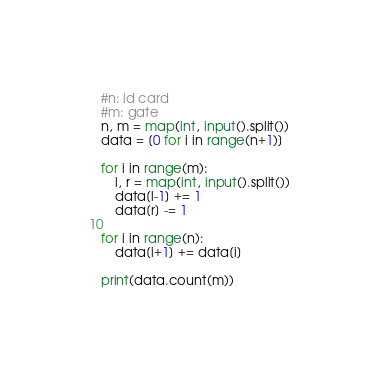<code> <loc_0><loc_0><loc_500><loc_500><_Python_>#n: id card
#m: gate
n, m = map(int, input().split())
data = [0 for i in range(n+1)]

for i in range(m):
    l, r = map(int, input().split())
    data[l-1] += 1
    data[r] -= 1

for i in range(n):
    data[i+1] += data[i]

print(data.count(m))</code> 